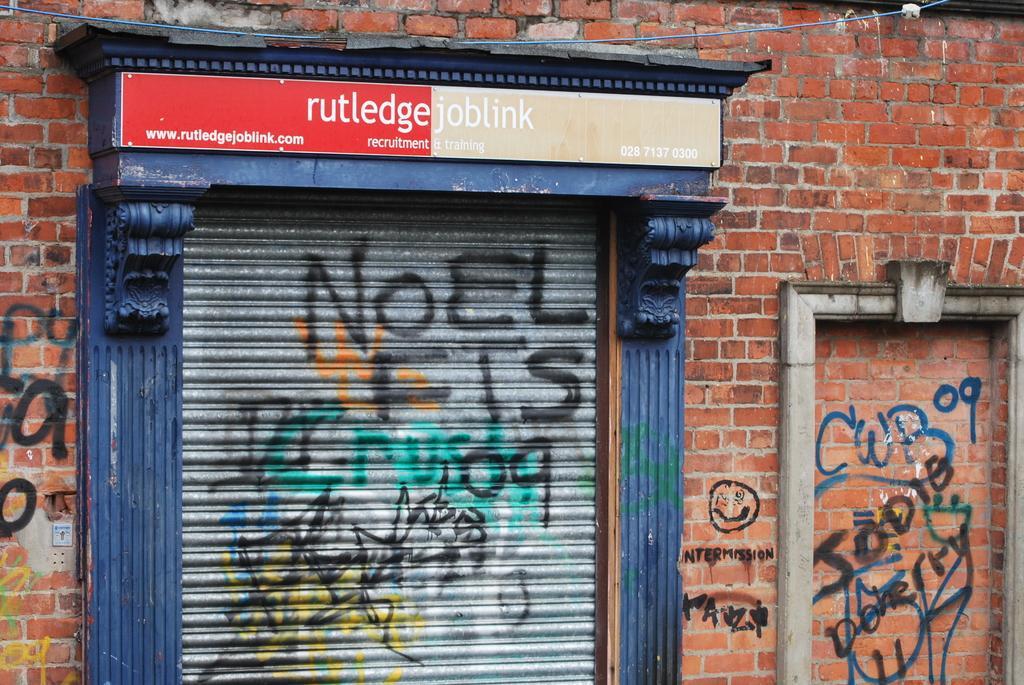Can you describe this image briefly? In this picture I can see a board, there are some scribblings on the shutter and on the wall. 